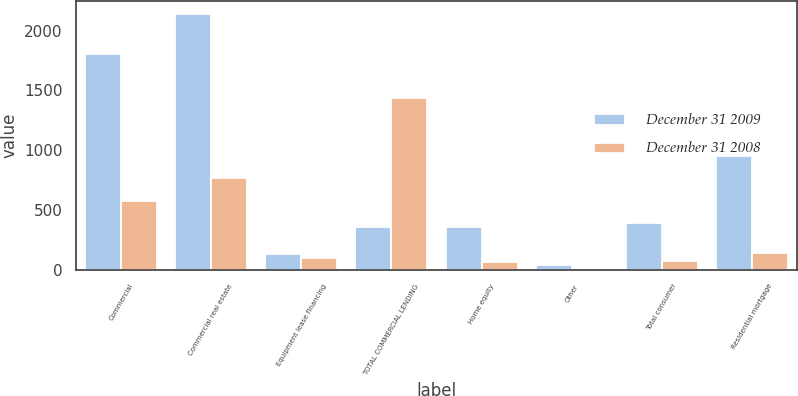Convert chart to OTSL. <chart><loc_0><loc_0><loc_500><loc_500><stacked_bar_chart><ecel><fcel>Commercial<fcel>Commercial real estate<fcel>Equipment lease financing<fcel>TOTAL COMMERCIAL LENDING<fcel>Home equity<fcel>Other<fcel>Total consumer<fcel>Residential mortgage<nl><fcel>December 31 2009<fcel>1806<fcel>2140<fcel>130<fcel>356<fcel>356<fcel>36<fcel>392<fcel>955<nl><fcel>December 31 2008<fcel>576<fcel>766<fcel>97<fcel>1439<fcel>66<fcel>4<fcel>70<fcel>139<nl></chart> 